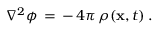<formula> <loc_0><loc_0><loc_500><loc_500>\nabla ^ { 2 } \phi \, = \, - \, 4 \pi \, \rho ( { x } , t ) \, .</formula> 